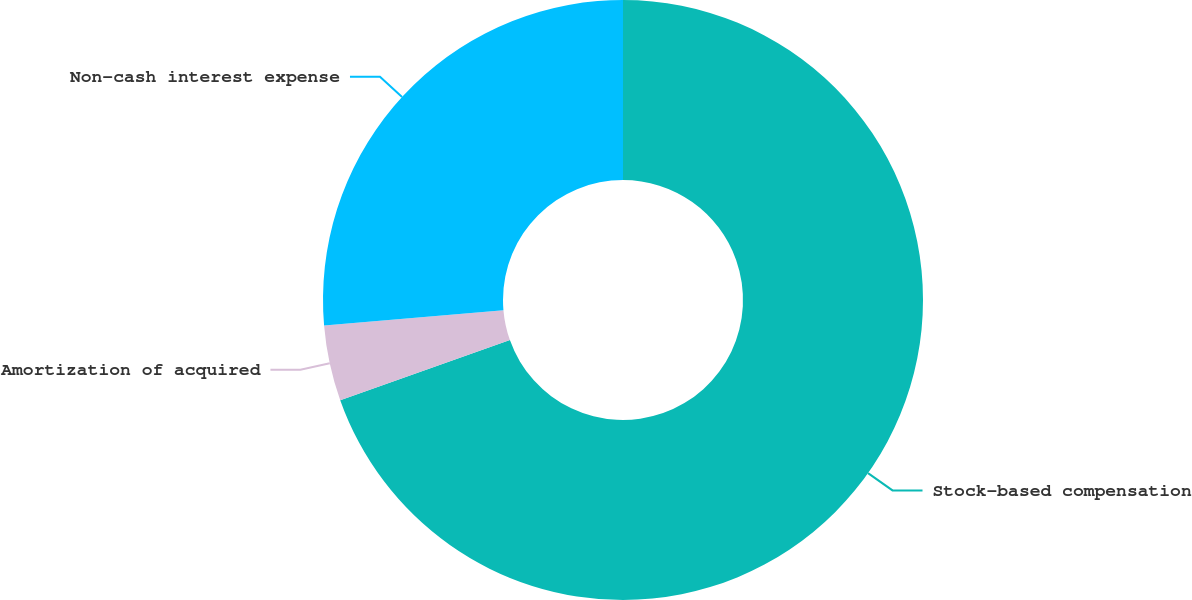Convert chart. <chart><loc_0><loc_0><loc_500><loc_500><pie_chart><fcel>Stock-based compensation<fcel>Amortization of acquired<fcel>Non-cash interest expense<nl><fcel>69.58%<fcel>4.07%<fcel>26.35%<nl></chart> 